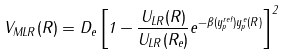Convert formula to latex. <formula><loc_0><loc_0><loc_500><loc_500>V _ { M L R } ( R ) = D _ { e } \left [ 1 - \frac { U _ { L R } ( R ) } { U _ { L R } ( R _ { e } ) } e ^ { - \beta ( y ^ { r e f } _ { p } ) y ^ { e } _ { p } ( R ) } \right ] ^ { 2 }</formula> 